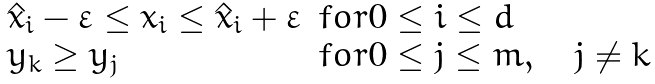<formula> <loc_0><loc_0><loc_500><loc_500>\begin{array} { l l } \hat { x } _ { i } - \varepsilon \leq x _ { i } \leq \hat { x } _ { i } + \varepsilon & f o r 0 \leq i \leq d \\ y _ { k } \geq y _ { j } & f o r 0 \leq j \leq m , \quad j \neq k \end{array}</formula> 